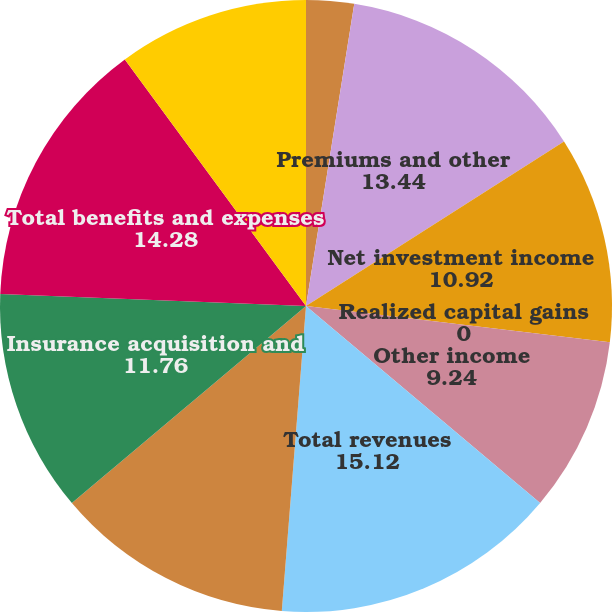<chart> <loc_0><loc_0><loc_500><loc_500><pie_chart><fcel>Years Ended December 31 (in<fcel>Premiums and other<fcel>Net investment income<fcel>Realized capital gains<fcel>Other income<fcel>Total revenues<fcel>Incurred policy losses and<fcel>Insurance acquisition and<fcel>Total benefits and expenses<fcel>Income before income taxes<nl><fcel>2.52%<fcel>13.44%<fcel>10.92%<fcel>0.0%<fcel>9.24%<fcel>15.12%<fcel>12.6%<fcel>11.76%<fcel>14.28%<fcel>10.08%<nl></chart> 